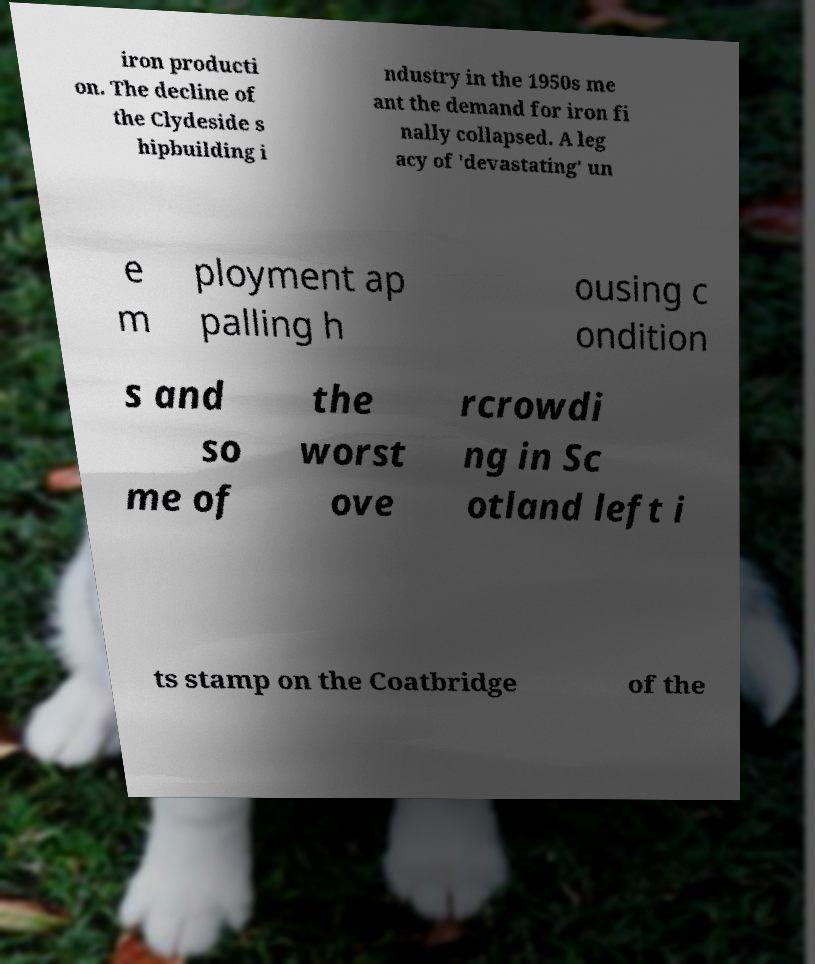What messages or text are displayed in this image? I need them in a readable, typed format. iron producti on. The decline of the Clydeside s hipbuilding i ndustry in the 1950s me ant the demand for iron fi nally collapsed. A leg acy of 'devastating' un e m ployment ap palling h ousing c ondition s and so me of the worst ove rcrowdi ng in Sc otland left i ts stamp on the Coatbridge of the 